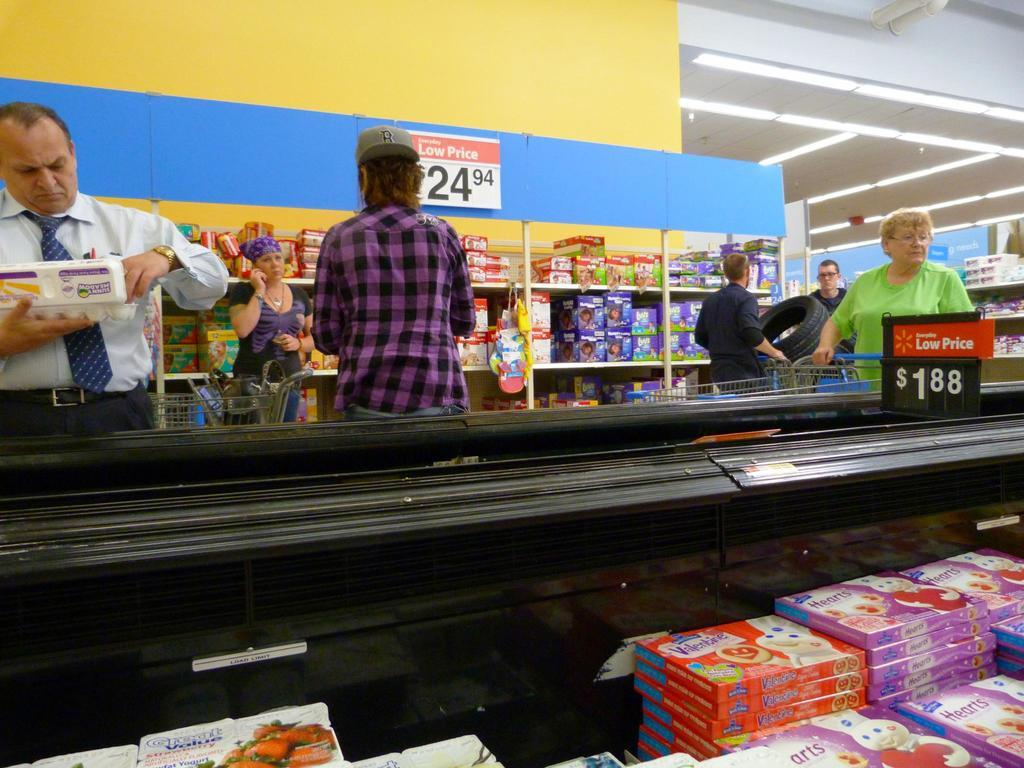Provide a one-sentence caption for the provided image. A group of shoppers at Walmart looking at items costing a new Low Price of 24.94. 